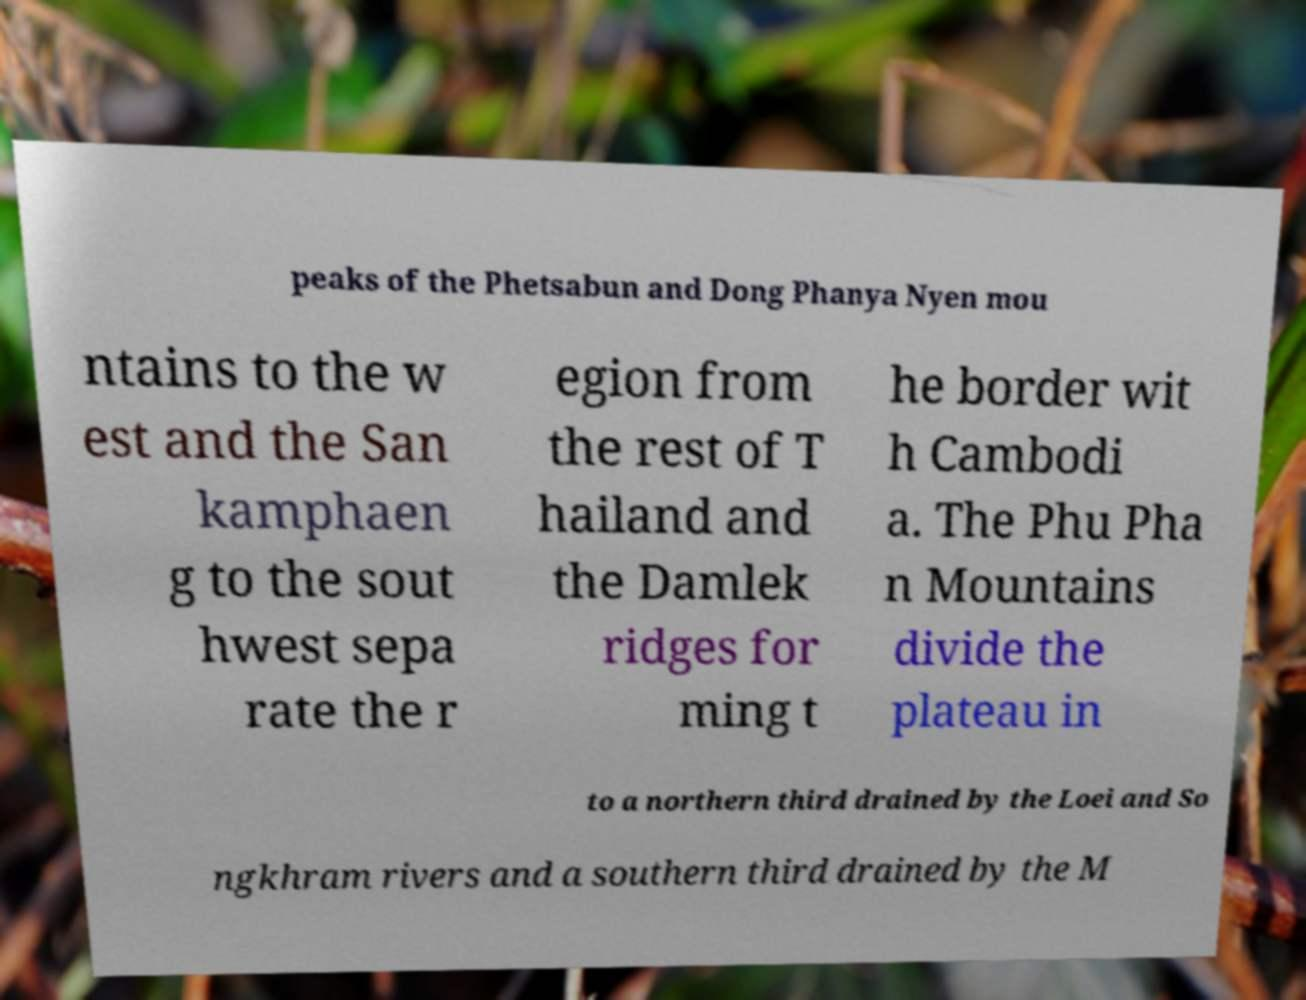Can you read and provide the text displayed in the image?This photo seems to have some interesting text. Can you extract and type it out for me? peaks of the Phetsabun and Dong Phanya Nyen mou ntains to the w est and the San kamphaen g to the sout hwest sepa rate the r egion from the rest of T hailand and the Damlek ridges for ming t he border wit h Cambodi a. The Phu Pha n Mountains divide the plateau in to a northern third drained by the Loei and So ngkhram rivers and a southern third drained by the M 